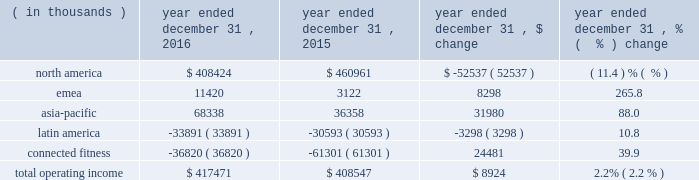Operating income ( loss ) by segment is summarized below: .
The increase in total operating income was driven by the following : 2022 operating income in our north america operating segment decreased $ 52.5 million to $ 408.4 million in 2016 from $ 461.0 million in 2015 primarily due to decreases in gross margin discussed above in the consolidated results of operations and $ 17.0 million in expenses related to the liquidation of the sports authority , comprised of $ 15.2 million in bad debt expense and $ 1.8 million of in-store fixture impairment .
In addition , this decrease reflects the movement of $ 11.1 million in expenses resulting from a strategic shift in headcount supporting our global business from our connected fitness operating segment to north america .
This decrease is partially offset by the increases in revenue discussed above in the consolidated results of operations .
2022 operating income in our emea operating segment increased $ 8.3 million to $ 11.4 million in 2016 from $ 3.1 million in 2015 primarily due to sales growth discussed above and reductions in incentive compensation .
This increase was offset by investments in sports marketing and infrastructure for future growth .
2022 operating income in our asia-pacific operating segment increased $ 31.9 million to $ 68.3 million in 2016 from $ 36.4 million in 2015 primarily due to sales growth discussed above and reductions in incentive compensation .
This increase was offset by investments in our direct-to-consumer business and entry into new territories .
2022 operating loss in our latin america operating segment increased $ 3.3 million to $ 33.9 million in 2016 from $ 30.6 million in 2015 primarily due to increased investments to support growth in the region and the economic challenges in brazil during the period .
This increase in operating loss was offset by sales growth discussed above and reductions in incentive compensation .
2022 operating loss in our connected fitness segment decreased $ 24.5 million to $ 36.8 million in 2016 from $ 61.3 million in 2015 primarily driven by sales growth discussed above .
Seasonality historically , we have recognized a majority of our net revenues and a significant portion of our income from operations in the last two quarters of the year , driven primarily by increased sales volume of our products during the fall selling season , including our higher priced cold weather products , along with a larger proportion of higher margin direct to consumer sales .
The level of our working capital generally reflects the seasonality and growth in our business .
We generally expect inventory , accounts payable and certain accrued expenses to be higher in the second and third quarters in preparation for the fall selling season. .
What percentage of operating income was the emea segment in 2016? 
Computations: (11420 / 417471)
Answer: 0.02736. 